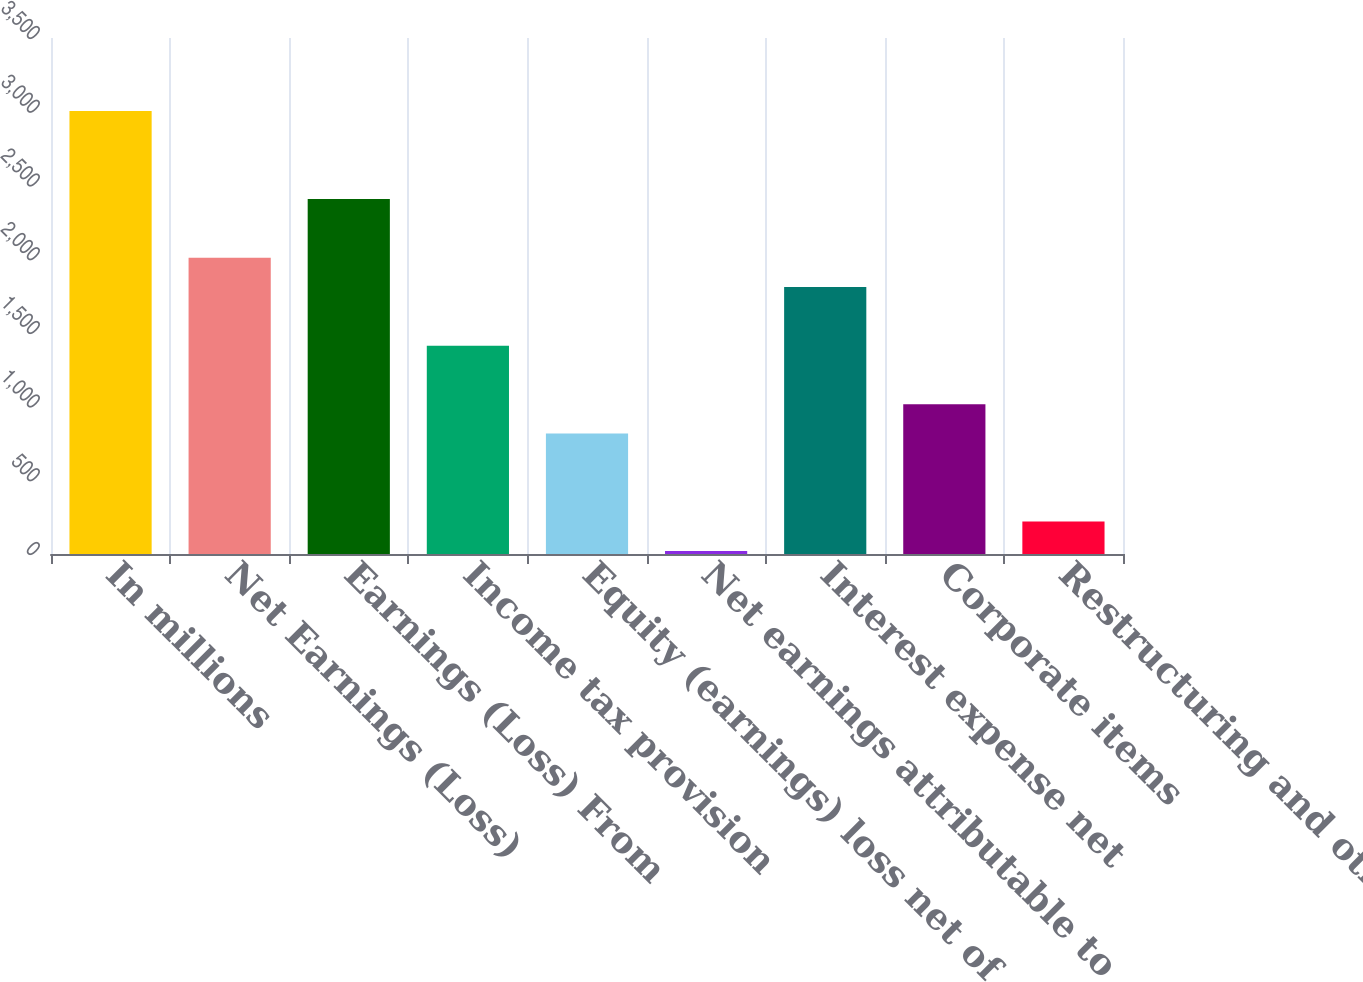Convert chart to OTSL. <chart><loc_0><loc_0><loc_500><loc_500><bar_chart><fcel>In millions<fcel>Net Earnings (Loss)<fcel>Earnings (Loss) From<fcel>Income tax provision<fcel>Equity (earnings) loss net of<fcel>Net earnings attributable to<fcel>Interest expense net<fcel>Corporate items<fcel>Restructuring and other<nl><fcel>3004.5<fcel>2010<fcel>2407.8<fcel>1413.3<fcel>816.6<fcel>21<fcel>1811.1<fcel>1015.5<fcel>219.9<nl></chart> 